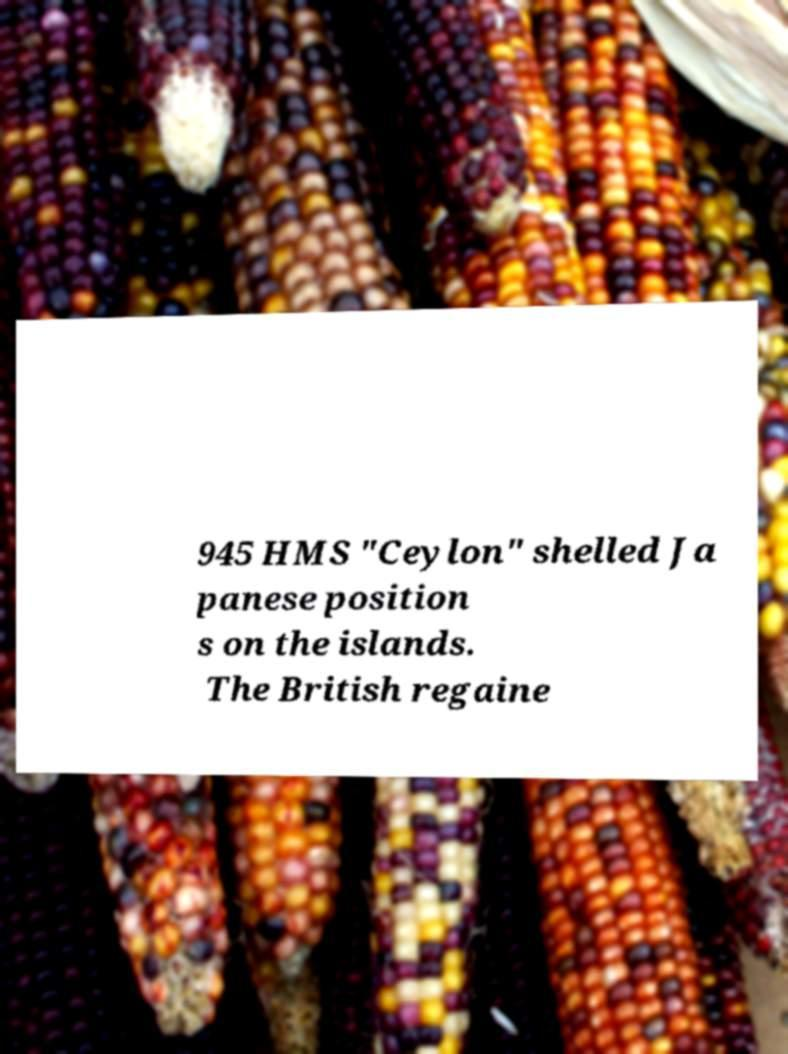Please identify and transcribe the text found in this image. 945 HMS "Ceylon" shelled Ja panese position s on the islands. The British regaine 